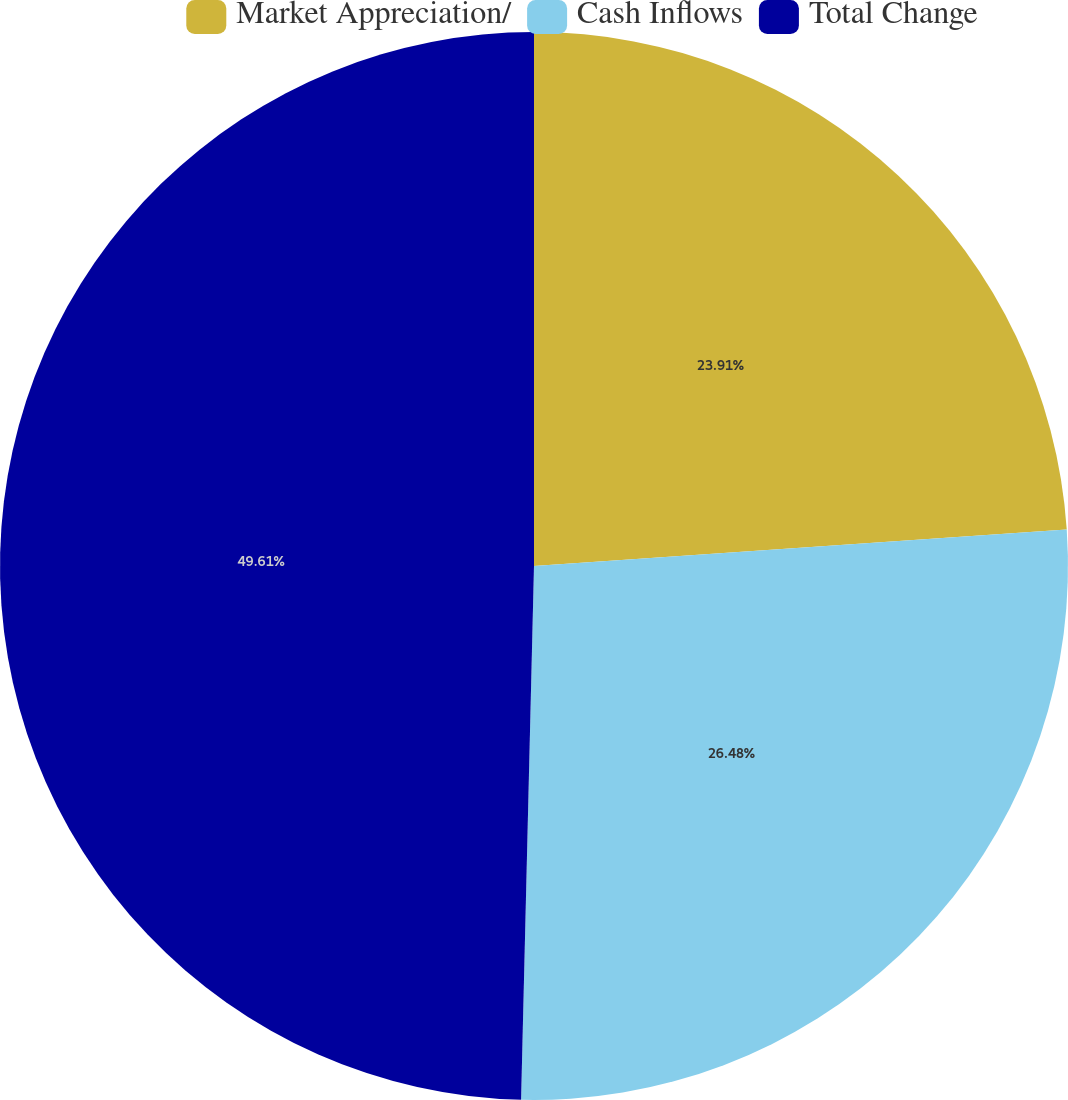Convert chart to OTSL. <chart><loc_0><loc_0><loc_500><loc_500><pie_chart><fcel>Market Appreciation/<fcel>Cash Inflows<fcel>Total Change<nl><fcel>23.91%<fcel>26.48%<fcel>49.62%<nl></chart> 